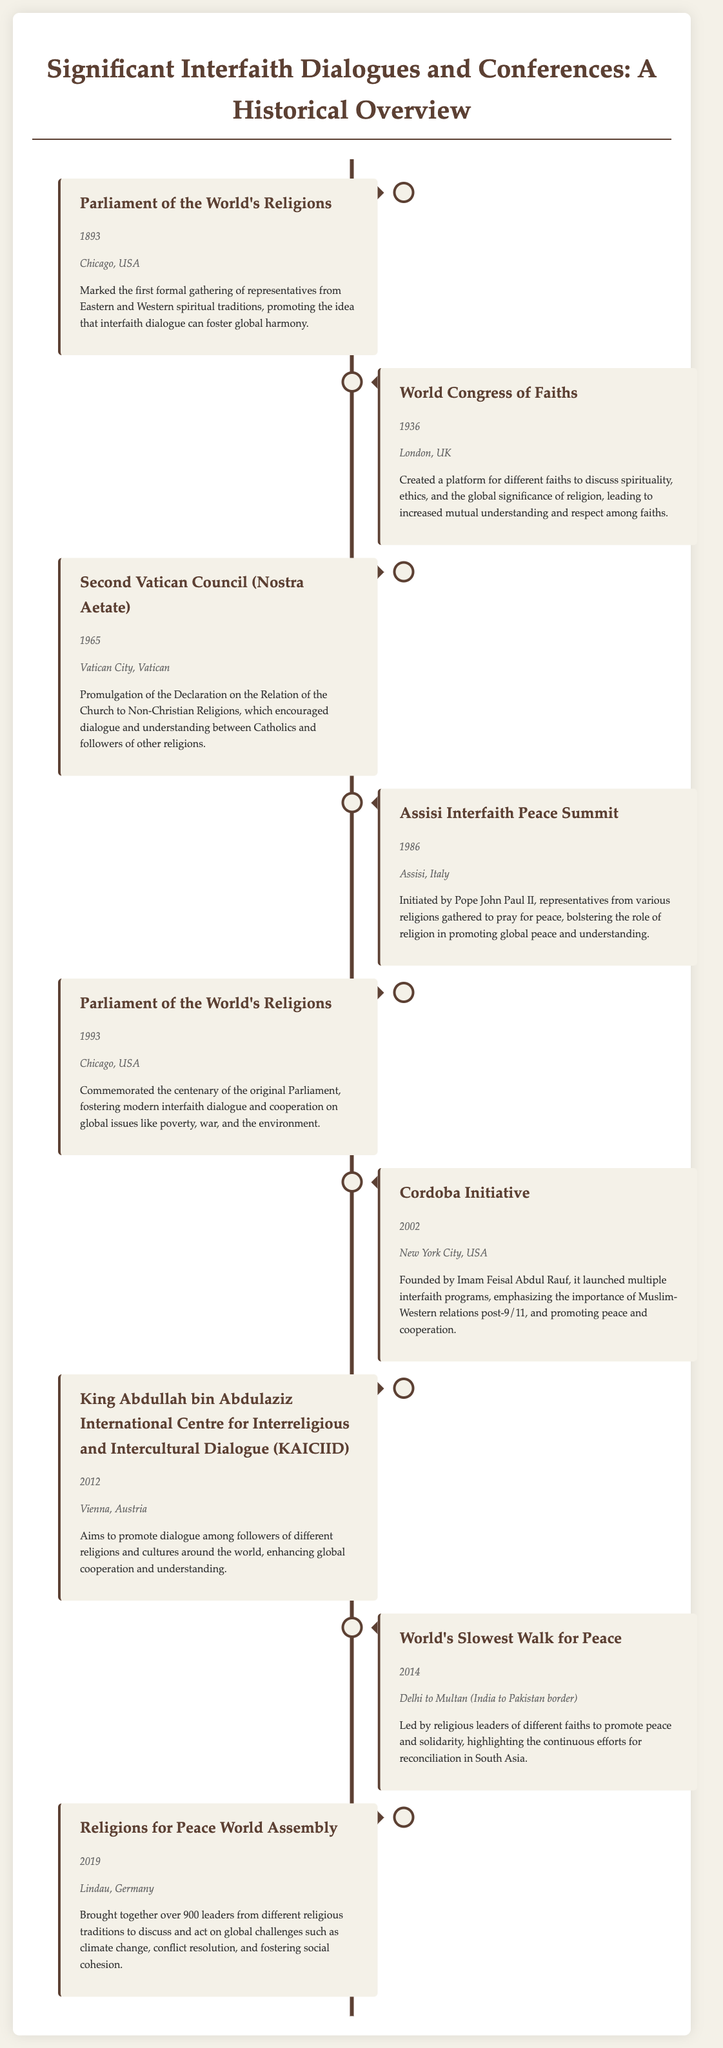What year was the Parliament of the World's Religions held? The document states that the Parliament of the World's Religions took place in 1893.
Answer: 1893 Where was the World Congress of Faiths held? According to the document, the World Congress of Faiths was held in London, UK.
Answer: London, UK Which event was initiated by Pope John Paul II? The document notes that the Assisi Interfaith Peace Summit was initiated by Pope John Paul II.
Answer: Assisi Interfaith Peace Summit What significant document was promulgated during the Second Vatican Council? The document mentions the Declaration on the Relation of the Church to Non-Christian Religions was promulgated during the Second Vatican Council.
Answer: Nostra Aetate How many leaders attended the Religions for Peace World Assembly in 2019? The document states that over 900 leaders from different religious traditions attended the Religions for Peace World Assembly in 2019.
Answer: over 900 What was the outcome of the Cordoba Initiative? The document describes the Cordoba Initiative as launching multiple interfaith programs emphasizing Muslim-Western relations.
Answer: Launched multiple interfaith programs What was the location of the 2012 interfaith center's establishment? The document indicates that the KAICIID was established in Vienna, Austria, in 2012.
Answer: Vienna, Austria Which event occurred in 2014 to promote peace in South Asia? The document states that the World's Slowest Walk for Peace took place in 2014 to promote peace in South Asia.
Answer: World's Slowest Walk for Peace What was the main theme of the Parliament of the World's Religions in 1993? The document notes that the 1993 Parliament focused on modern interfaith dialogue and cooperation on global issues like poverty and war.
Answer: Modern interfaith dialogue and cooperation 